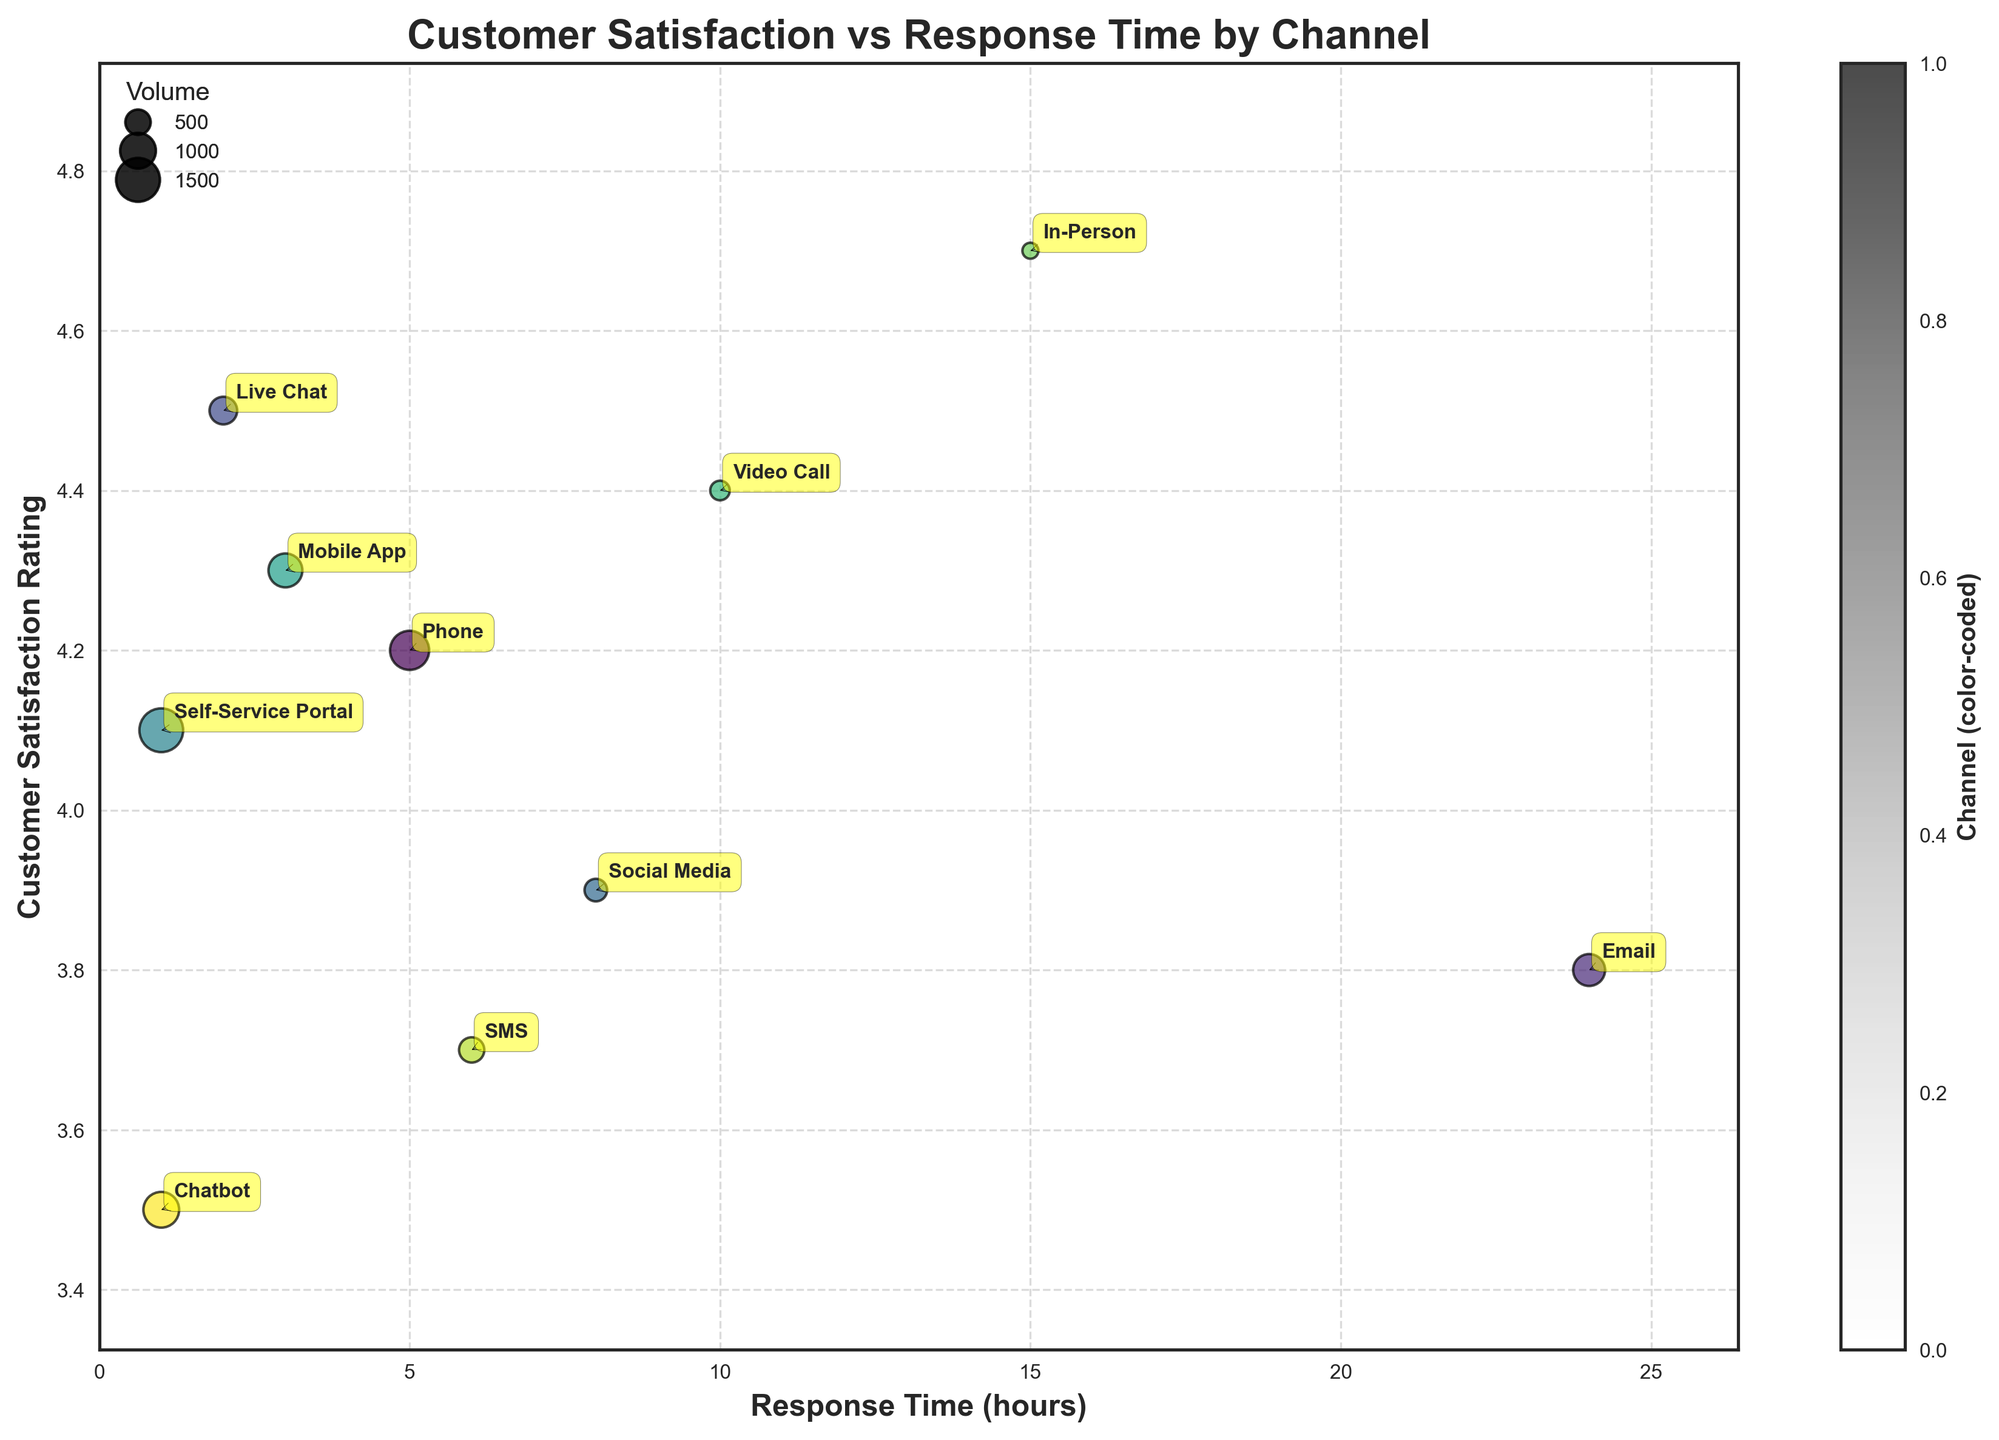What is the title of the figure? The title is prominently displayed at the top of the figure, serving as a succinct summary of the visualized data.
Answer: Customer Satisfaction vs Response Time by Channel Which service channel has the smallest response time? The channel with the smallest response time is located at the leftmost position on the x-axis.
Answer: Self-Service Portal and Chatbot What is the customer satisfaction rating for the Mobile App channel? To find the Mobile App's rating, locate the bubble labeled 'Mobile App' and observe its y-axis position.
Answer: 4.3 Which channel has the highest customer satisfaction rating, and what is that rating? Identify the bubble positioned highest on the y-axis, then read its corresponding satisfaction rating.
Answer: In-Person, 4.7 How does the response time of Email compare to that of In-Person? Locate the Email and In-Person bubbles on the x-axis, then compare their positions to determine which is greater or lesser.
Answer: Email has a longer response time (24 hours vs. 15 hours) What is the approximate volume of inquiries for the Chatbot channel, and how can you tell? The size of each bubble represents the volume of inquiries; locate the Chatbot bubble and estimate its size relative to the legend.
Answer: Approximately 1000 What is the average satisfaction rating of Email and SMS channels? Add the satisfaction ratings of Email (3.8) and SMS (3.7) and divide by 2 to find the average.
Answer: 3.75 Which channel delivers the quickest response time after Self-Service Portal and Chatbot, and what is that time? Excluding Self-Service Portal and Chatbot, identify the bubble closest to the origin on the x-axis and read its response time.
Answer: Live Chat, 2 hours How does customer satisfaction correlate with response time based on the figure? Examine the overall trend in the scatter plot by observing how the satisfaction ratings change as response times increase.
Answer: Generally, shorter response times correlate with higher satisfaction What is the combined volume of inquiries for the top three channels by customer satisfaction rating? Identify the three bubbles with the highest y-axis positions, then sum their volumes: In-Person (200), Live Chat (600), and Video Call (300).
Answer: 1100 